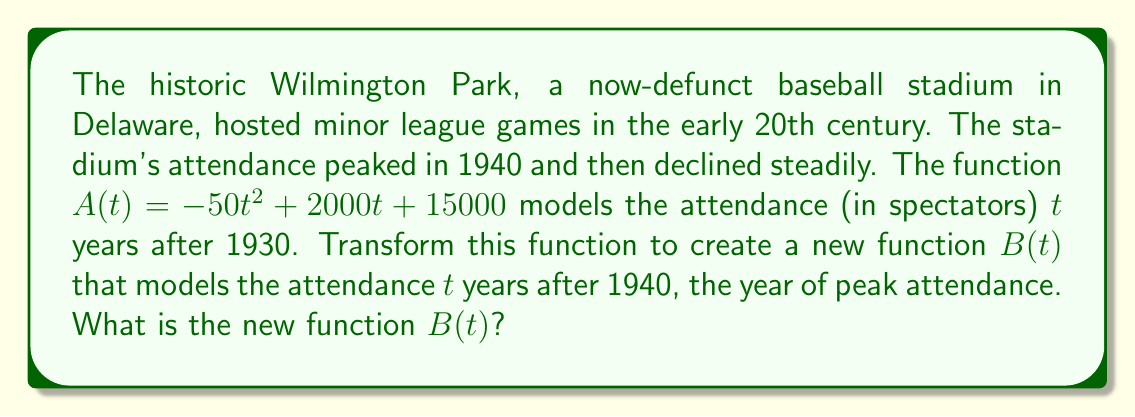Help me with this question. To transform the function $A(t)$ to $B(t)$, we need to shift the function 10 years to the left, as 1940 is 10 years after 1930. This means we need to replace every $t$ in the original function with $(t+10)$.

Steps:
1. Start with the original function: $A(t) = -50t^2 + 2000t + 15000$
2. Replace every $t$ with $(t+10)$:
   $B(t) = -50(t+10)^2 + 2000(t+10) + 15000$
3. Expand the squared term:
   $B(t) = -50(t^2 + 20t + 100) + 2000(t+10) + 15000$
4. Multiply out the terms:
   $B(t) = -50t^2 - 1000t - 5000 + 2000t + 20000 + 15000$
5. Combine like terms:
   $B(t) = -50t^2 + 1000t + 30000$

Therefore, the new function $B(t)$ that models the attendance $t$ years after 1940 is $B(t) = -50t^2 + 1000t + 30000$.
Answer: $B(t) = -50t^2 + 1000t + 30000$ 